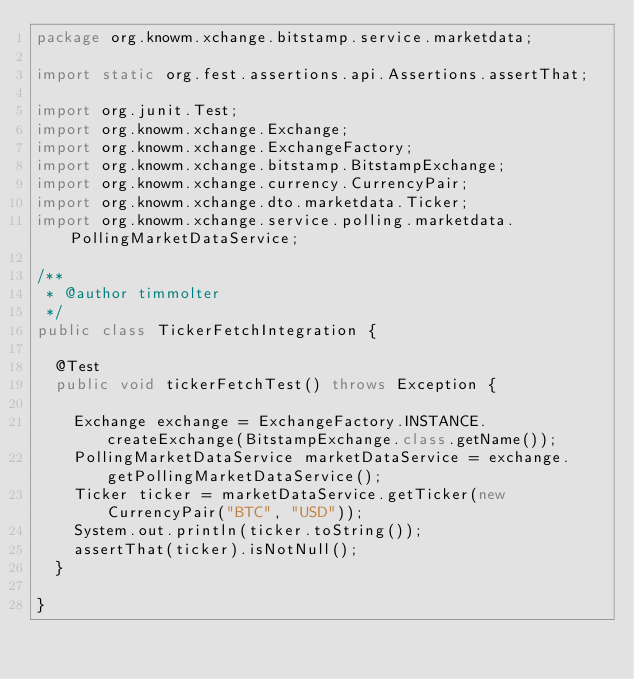Convert code to text. <code><loc_0><loc_0><loc_500><loc_500><_Java_>package org.knowm.xchange.bitstamp.service.marketdata;

import static org.fest.assertions.api.Assertions.assertThat;

import org.junit.Test;
import org.knowm.xchange.Exchange;
import org.knowm.xchange.ExchangeFactory;
import org.knowm.xchange.bitstamp.BitstampExchange;
import org.knowm.xchange.currency.CurrencyPair;
import org.knowm.xchange.dto.marketdata.Ticker;
import org.knowm.xchange.service.polling.marketdata.PollingMarketDataService;

/**
 * @author timmolter
 */
public class TickerFetchIntegration {

  @Test
  public void tickerFetchTest() throws Exception {

    Exchange exchange = ExchangeFactory.INSTANCE.createExchange(BitstampExchange.class.getName());
    PollingMarketDataService marketDataService = exchange.getPollingMarketDataService();
    Ticker ticker = marketDataService.getTicker(new CurrencyPair("BTC", "USD"));
    System.out.println(ticker.toString());
    assertThat(ticker).isNotNull();
  }

}
</code> 